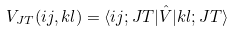Convert formula to latex. <formula><loc_0><loc_0><loc_500><loc_500>V _ { J T } ( i j , k l ) = \langle i j ; J T | \hat { V } | k l ; J T \rangle</formula> 